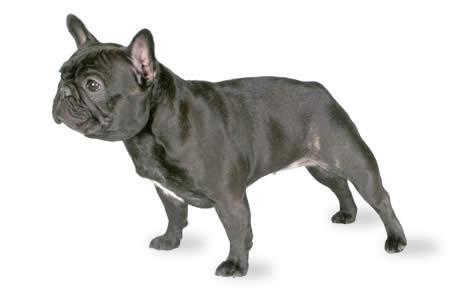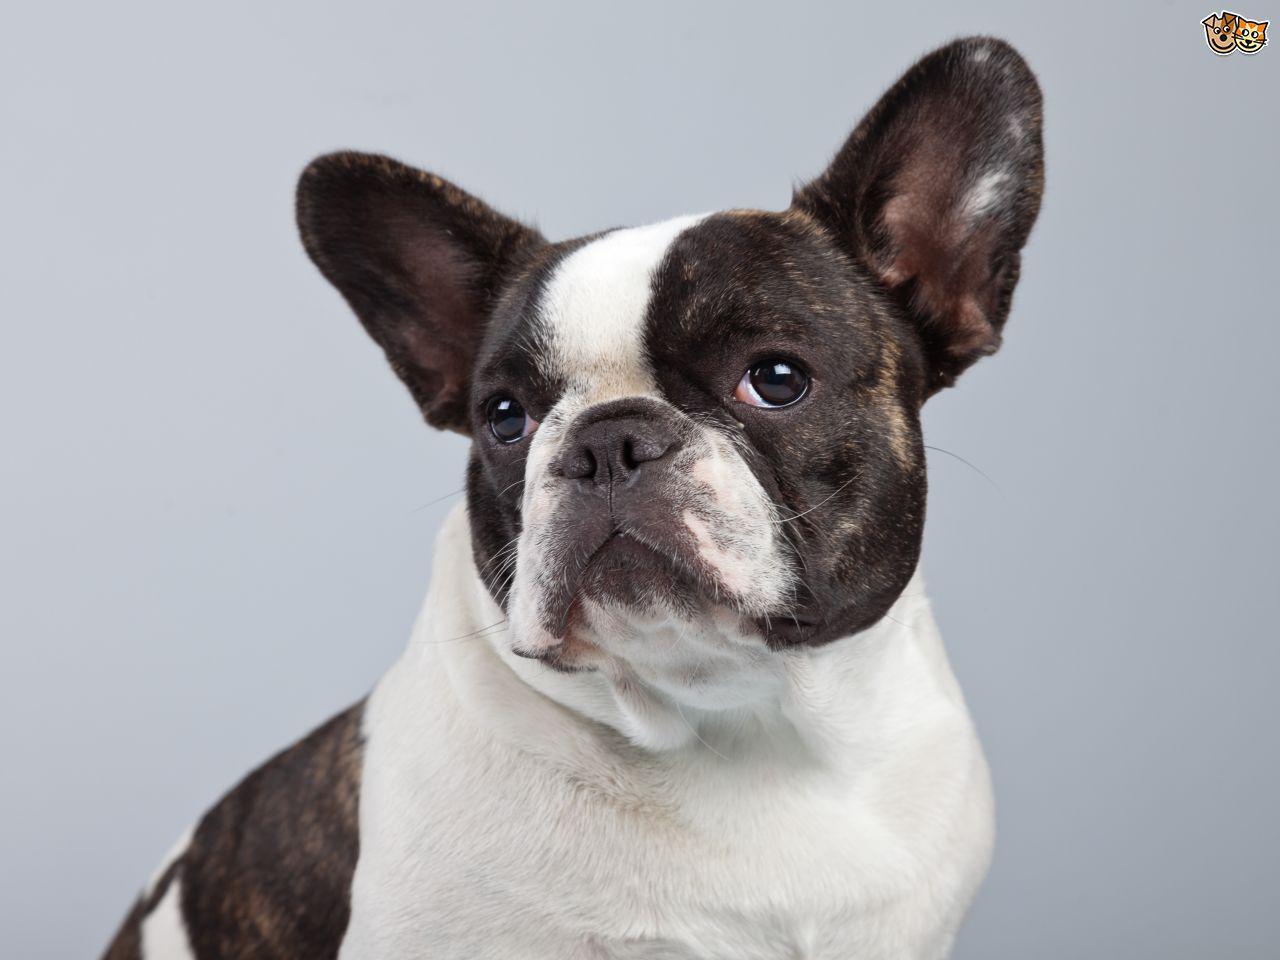The first image is the image on the left, the second image is the image on the right. Examine the images to the left and right. Is the description "There are eight dog legs visible" accurate? Answer yes or no. No. 